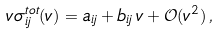<formula> <loc_0><loc_0><loc_500><loc_500>v \sigma ^ { t o t } _ { i j } ( v ) = a _ { i j } + b _ { i j } \, v + \mathcal { O } ( v ^ { 2 } ) \, ,</formula> 